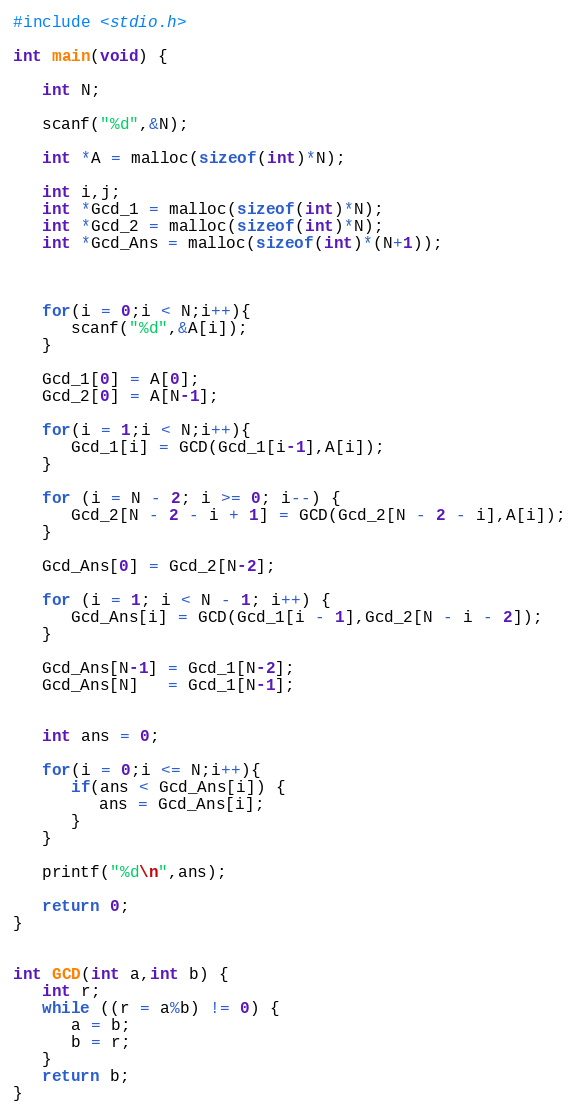<code> <loc_0><loc_0><loc_500><loc_500><_C_>#include <stdio.h>

int main(void) {
   
   int N;
   
   scanf("%d",&N);
   
   int *A = malloc(sizeof(int)*N);
   
   int i,j;
   int *Gcd_1 = malloc(sizeof(int)*N);
   int *Gcd_2 = malloc(sizeof(int)*N);
   int *Gcd_Ans = malloc(sizeof(int)*(N+1));
   
   
   
   for(i = 0;i < N;i++){
      scanf("%d",&A[i]);
   }
   
   Gcd_1[0] = A[0];
   Gcd_2[0] = A[N-1];
   
   for(i = 1;i < N;i++){
      Gcd_1[i] = GCD(Gcd_1[i-1],A[i]);
   }
   
   for (i = N - 2; i >= 0; i--) {
      Gcd_2[N - 2 - i + 1] = GCD(Gcd_2[N - 2 - i],A[i]);
   }
   
   Gcd_Ans[0] = Gcd_2[N-2];
   
   for (i = 1; i < N - 1; i++) {
      Gcd_Ans[i] = GCD(Gcd_1[i - 1],Gcd_2[N - i - 2]);
   }
   
   Gcd_Ans[N-1] = Gcd_1[N-2];
   Gcd_Ans[N]   = Gcd_1[N-1];
   
   
   int ans = 0;
   
   for(i = 0;i <= N;i++){
      if(ans < Gcd_Ans[i]) {
         ans = Gcd_Ans[i];
      }
   }
   
   printf("%d\n",ans);
   
   return 0;
}


int GCD(int a,int b) {
   int r;
   while ((r = a%b) != 0) {
      a = b;
      b = r;
   }
   return b;
}
</code> 